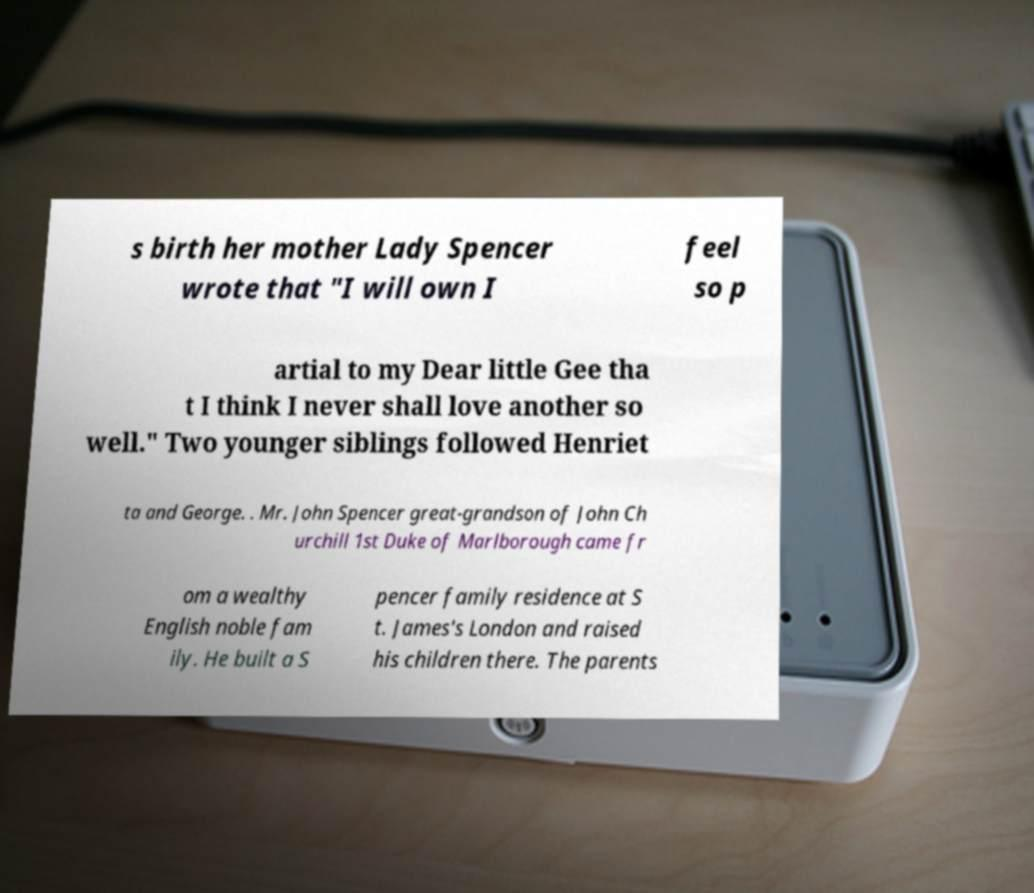For documentation purposes, I need the text within this image transcribed. Could you provide that? s birth her mother Lady Spencer wrote that "I will own I feel so p artial to my Dear little Gee tha t I think I never shall love another so well." Two younger siblings followed Henriet ta and George. . Mr. John Spencer great-grandson of John Ch urchill 1st Duke of Marlborough came fr om a wealthy English noble fam ily. He built a S pencer family residence at S t. James's London and raised his children there. The parents 